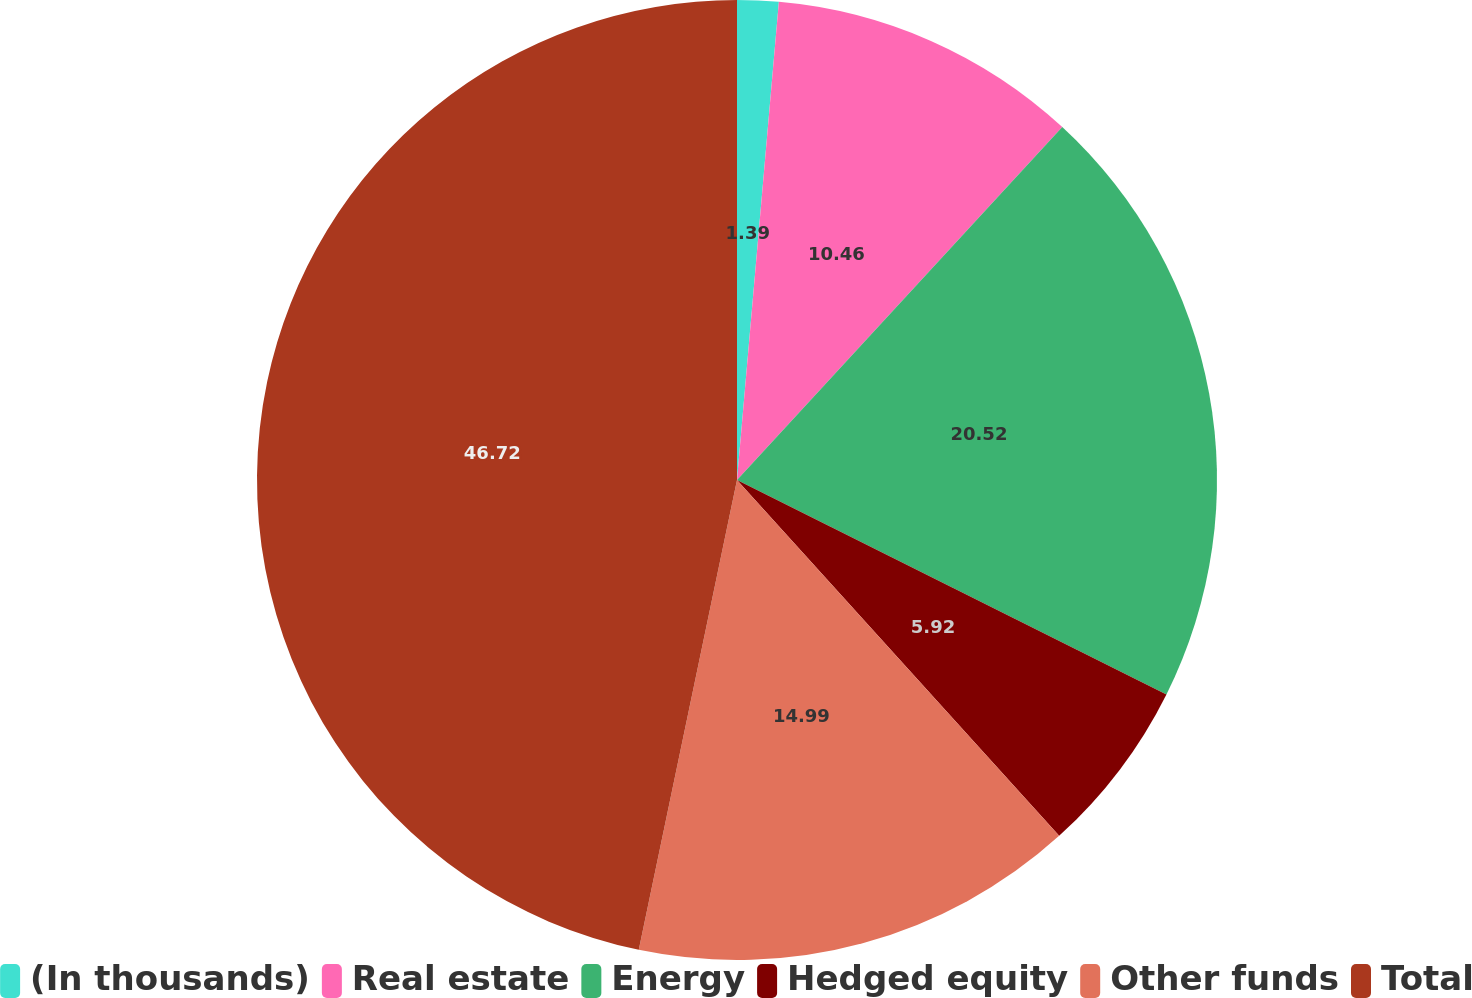Convert chart. <chart><loc_0><loc_0><loc_500><loc_500><pie_chart><fcel>(In thousands)<fcel>Real estate<fcel>Energy<fcel>Hedged equity<fcel>Other funds<fcel>Total<nl><fcel>1.39%<fcel>10.46%<fcel>20.52%<fcel>5.92%<fcel>14.99%<fcel>46.72%<nl></chart> 